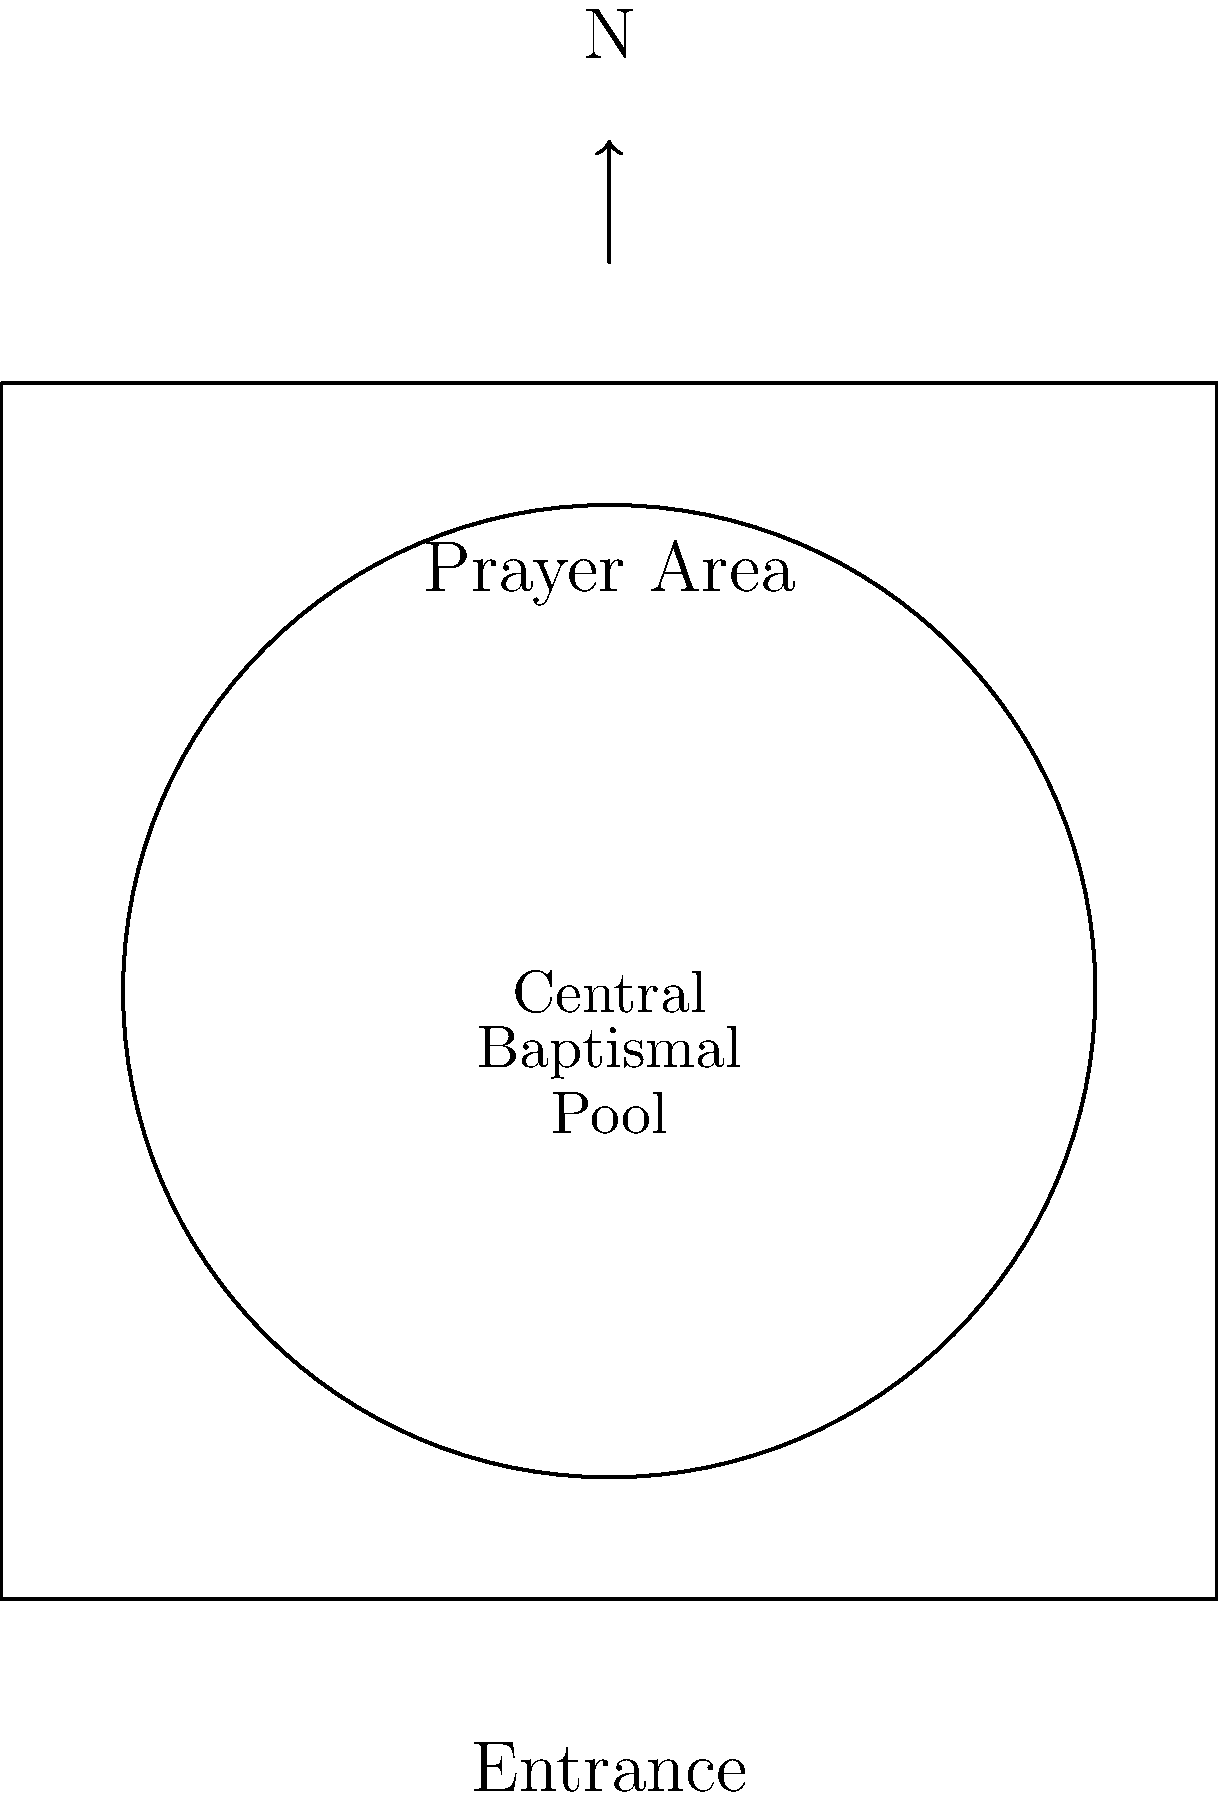Analyze the layout of this Mandaean place of worship. How does the central feature differ from typical layouts in other Abrahamic faiths, and what does this reveal about Mandaean religious priorities? 1. The diagram shows a square structure representing a Mandaean place of worship, known as a mandi.

2. The most prominent feature is the large circular area in the center, which represents the baptismal pool or yardna.

3. This central baptismal pool is unique to Mandaean places of worship and differs significantly from the layouts of other Abrahamic faiths:
   - In Christianity, the central focus is typically the altar or pulpit.
   - In Islam, the focal point is the mihrab, indicating the direction of Mecca.
   - In Judaism, the focus is on the ark containing the Torah scrolls.

4. The centrality and size of the baptismal pool in the Mandaean layout reveal the paramount importance of water rituals and purification in Mandaean religious practice.

5. This emphasis on water rituals is rooted in Mandaean beliefs about the sacredness of living water and its role in purification and connection to the divine.

6. The circular shape of the pool may symbolize the cyclical nature of life and the cosmos in Mandaean theology.

7. The surrounding area, labeled as the prayer area, is secondary to the central pool, further emphasizing the primacy of water rituals over other forms of worship.

8. This layout reflects the Mandaean focus on direct experience of the divine through purification rituals, rather than on scripture-based or clergy-led worship common in other Abrahamic faiths.
Answer: Central baptismal pool, emphasizing water rituals and purification as core to Mandaean worship, unlike other Abrahamic faiths' focus on scriptures or directional prayer. 